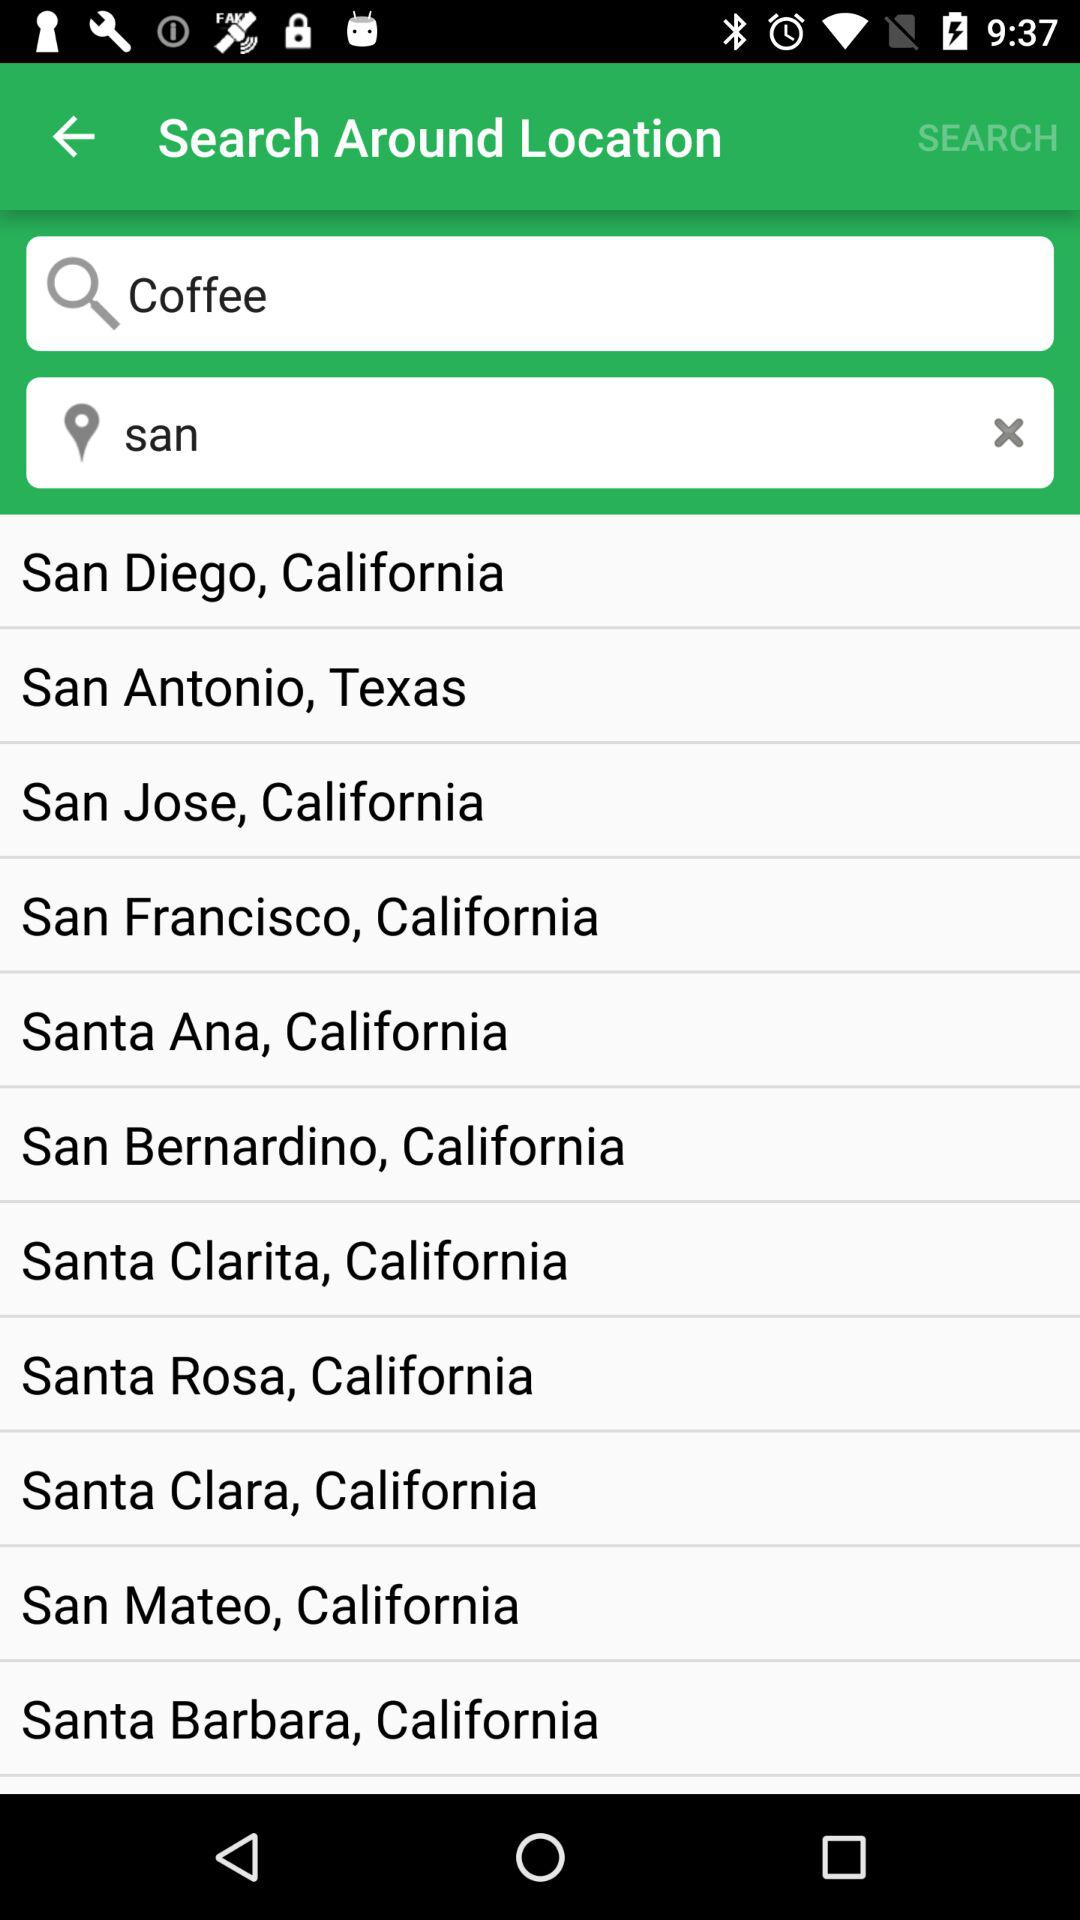What is the mentioned location? The mentioned locations are San Diego, California; San Antonio, Texas; San Jose, California; San Francisco, California; Santa Ana, California; San Bernardino, California; Santa Clarita, California; Santa Rosa, California; Santa Clara, California; San Mateo, California and Santa Barbara, California. 